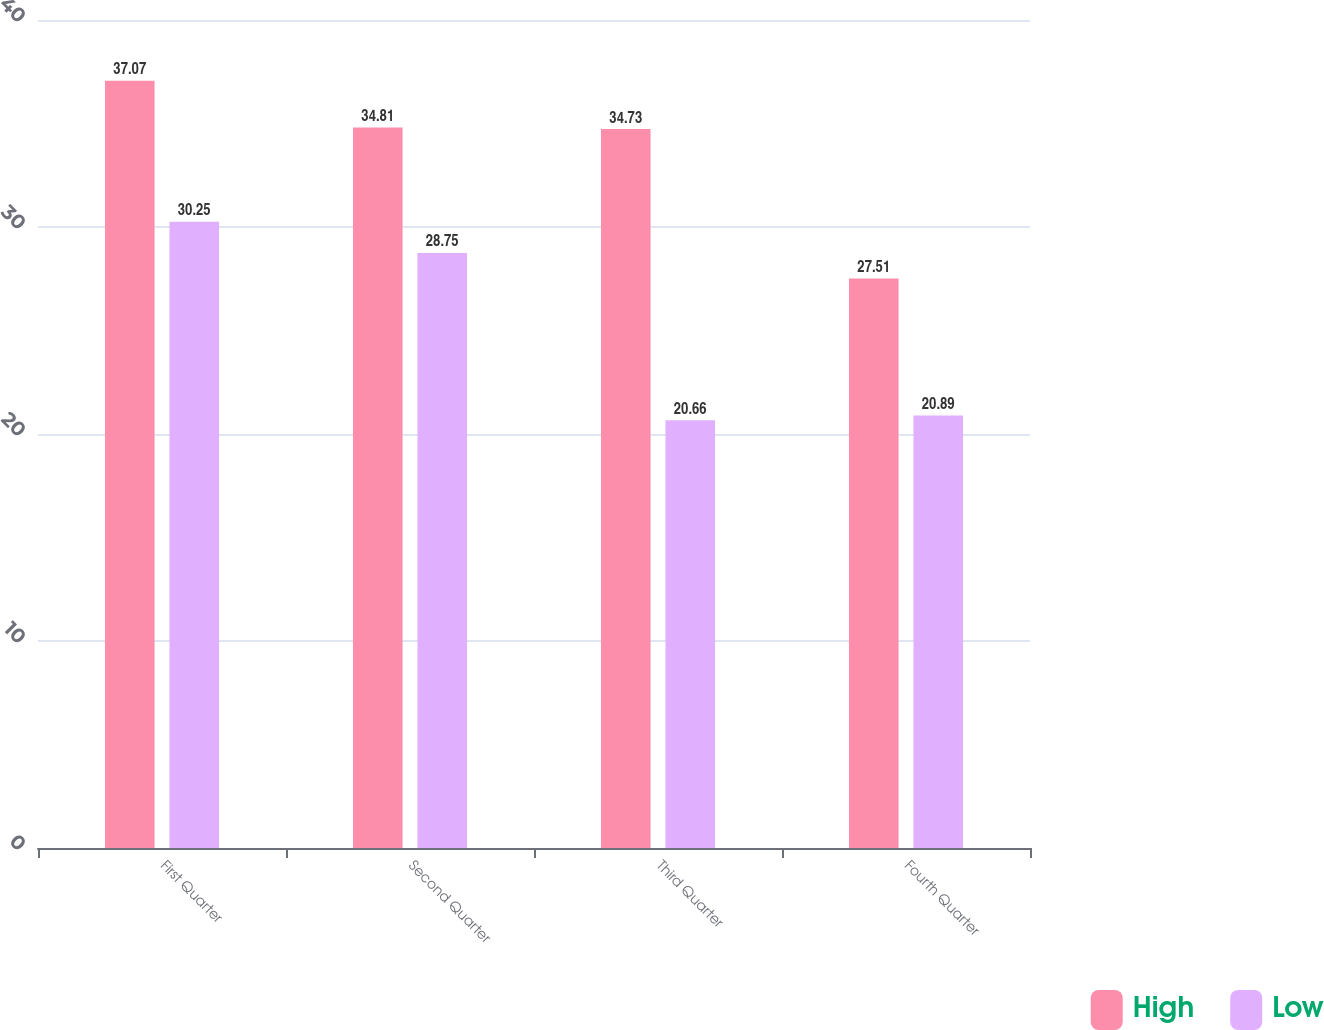<chart> <loc_0><loc_0><loc_500><loc_500><stacked_bar_chart><ecel><fcel>First Quarter<fcel>Second Quarter<fcel>Third Quarter<fcel>Fourth Quarter<nl><fcel>High<fcel>37.07<fcel>34.81<fcel>34.73<fcel>27.51<nl><fcel>Low<fcel>30.25<fcel>28.75<fcel>20.66<fcel>20.89<nl></chart> 